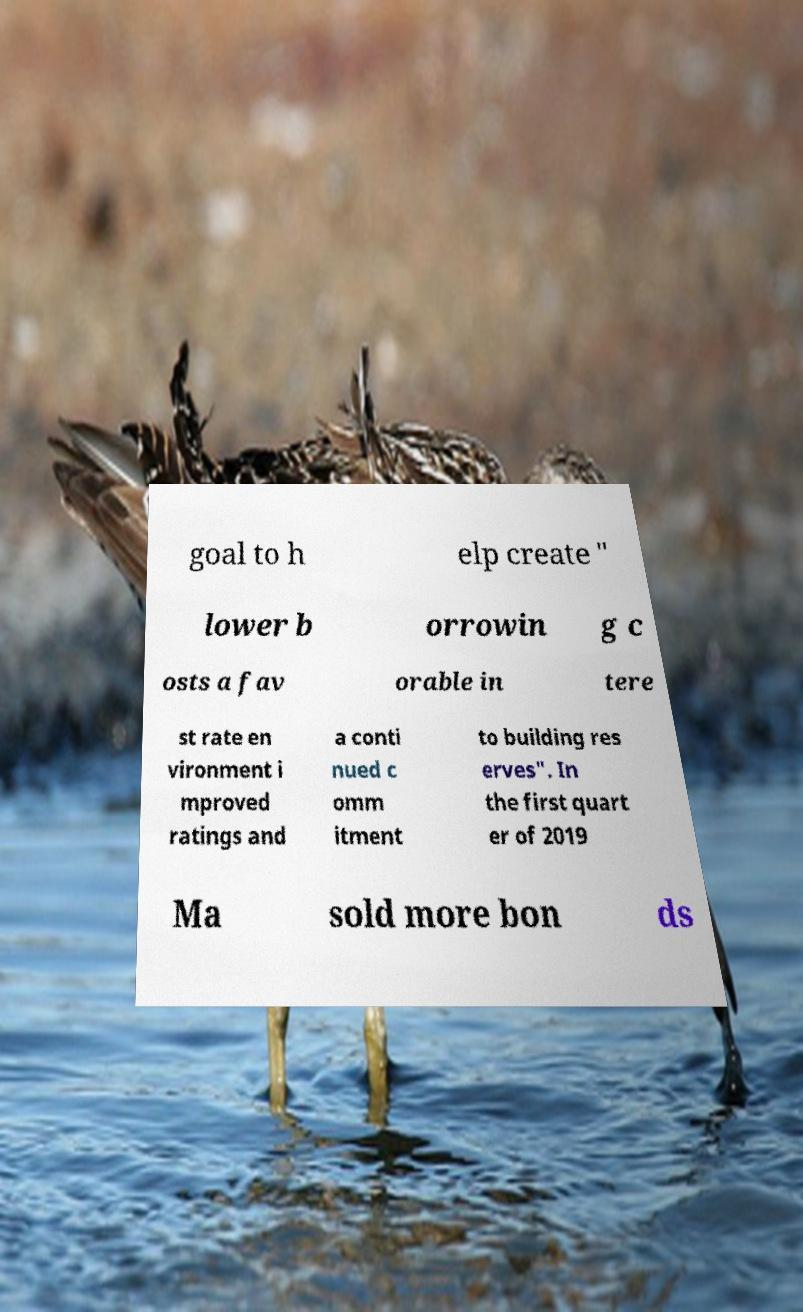For documentation purposes, I need the text within this image transcribed. Could you provide that? goal to h elp create " lower b orrowin g c osts a fav orable in tere st rate en vironment i mproved ratings and a conti nued c omm itment to building res erves". In the first quart er of 2019 Ma sold more bon ds 